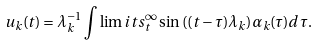<formula> <loc_0><loc_0><loc_500><loc_500>u _ { k } ( t ) = \lambda _ { k } ^ { - 1 } \int \lim i t s _ { t } ^ { \infty } \sin { ( ( t - \tau ) \lambda _ { k } ) } \alpha _ { k } ( \tau ) d \tau .</formula> 